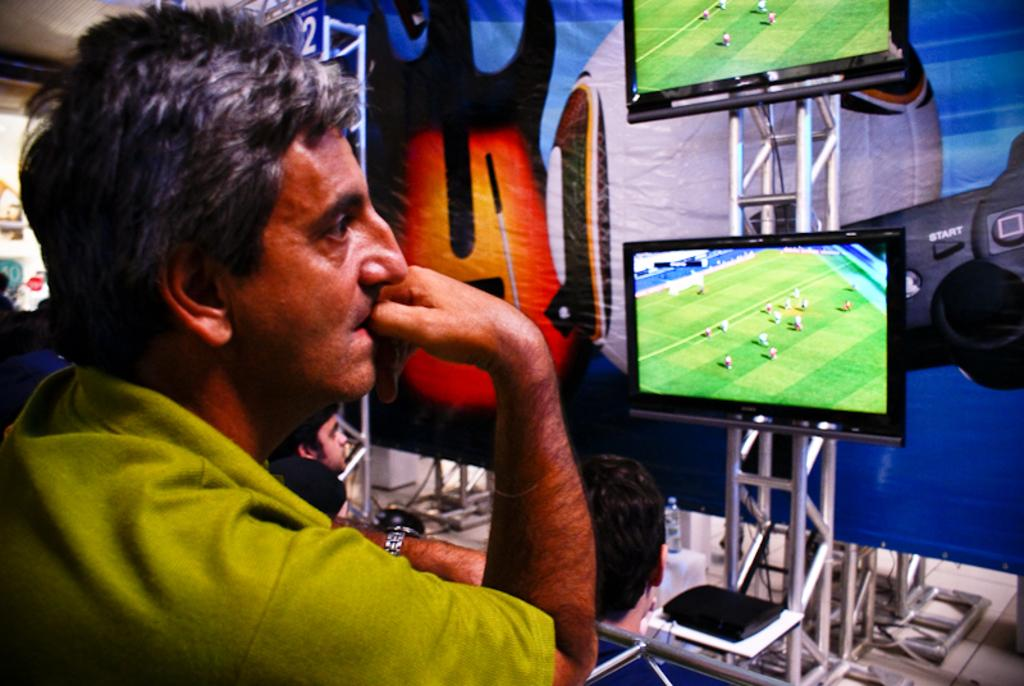What is the position of the person in the image? There is a person standing on the left side of the image. What can be seen on the right side of the image? There are persons, screens, a water bottle, and a poster on the right side of the image. What might the screens be used for? The screens could be used for displaying information or presentations. What is the purpose of the water bottle in the image? The water bottle is likely for hydration purposes. What type of board is being used for teaching in the image? There is no board present in the image, and no teaching activity is depicted. 